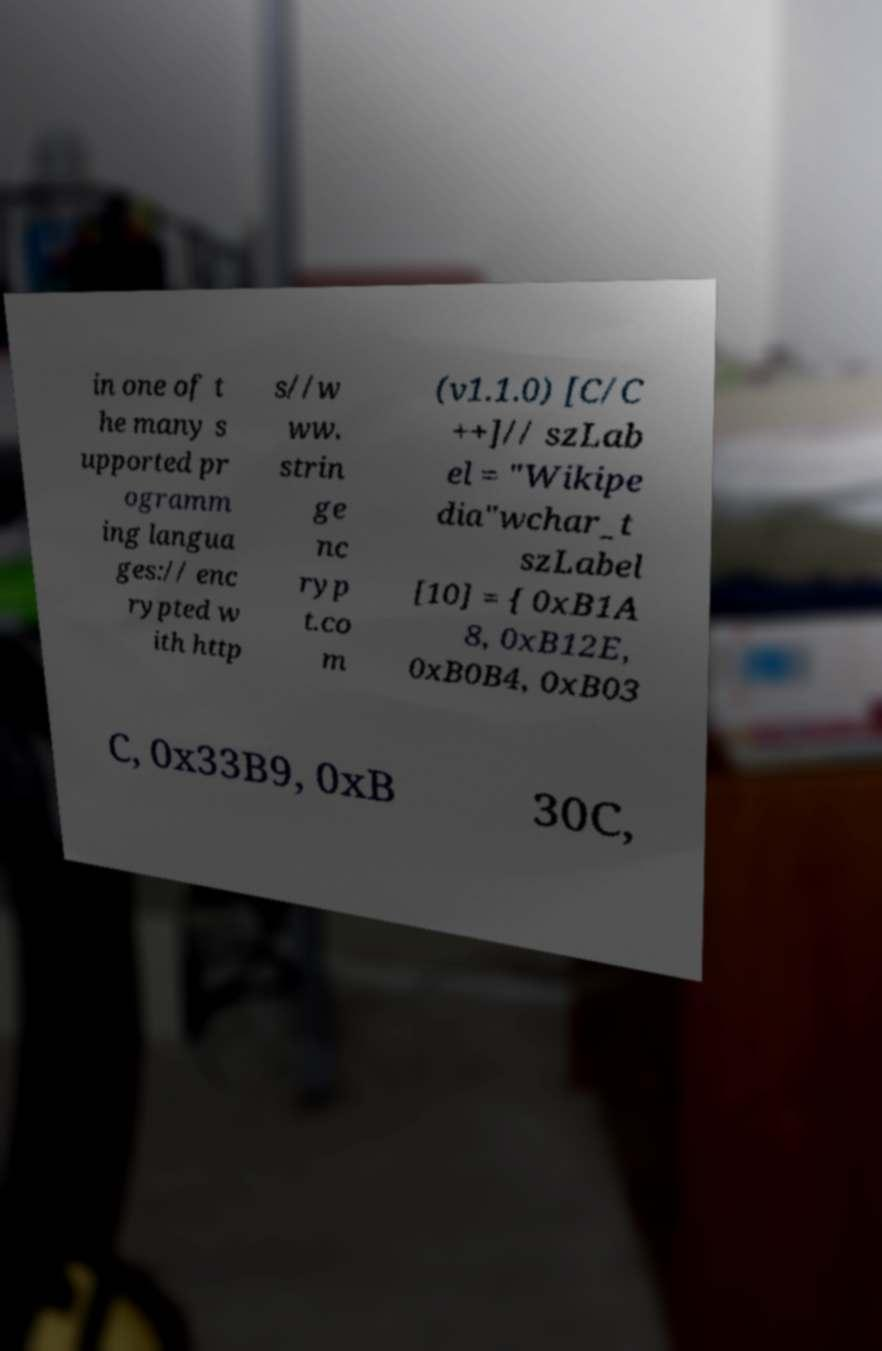Could you extract and type out the text from this image? in one of t he many s upported pr ogramm ing langua ges:// enc rypted w ith http s//w ww. strin ge nc ryp t.co m (v1.1.0) [C/C ++]// szLab el = "Wikipe dia"wchar_t szLabel [10] = { 0xB1A 8, 0xB12E, 0xB0B4, 0xB03 C, 0x33B9, 0xB 30C, 